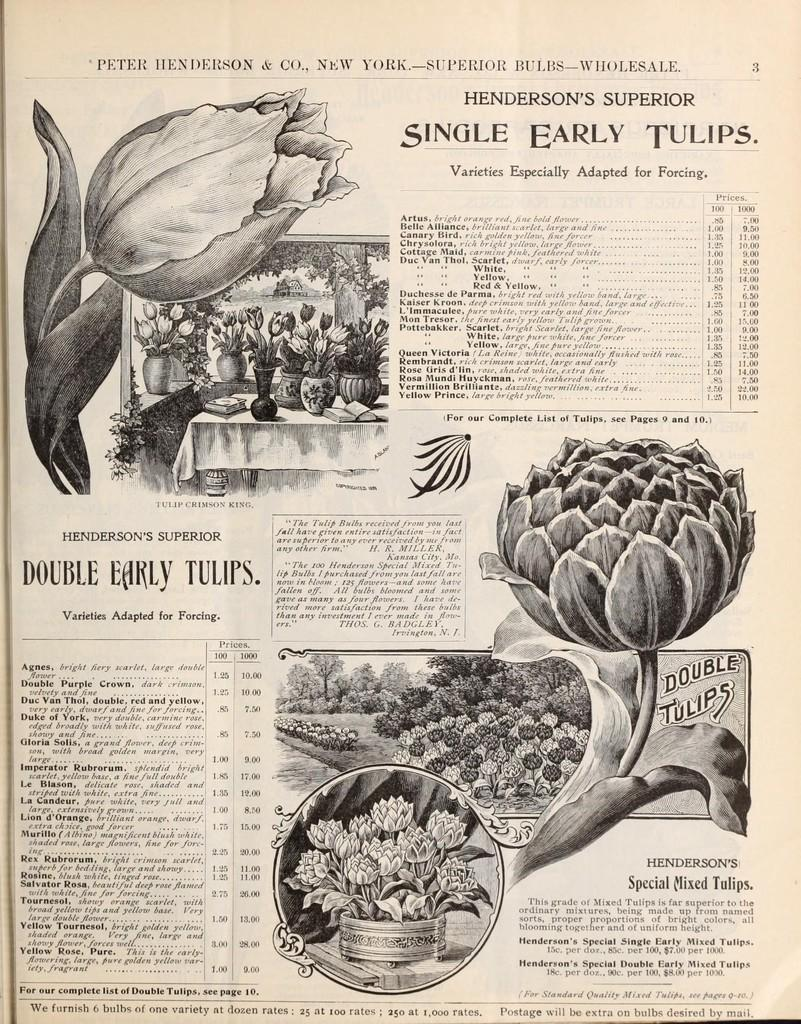What is depicted on the paper in the image? There are images of flowers on the paper. What else can be seen on the paper besides the images of flowers? There is writing on the paper. How many sisters does the creator of the paper have? There is no information about the creator of the paper or their sisters in the image. 